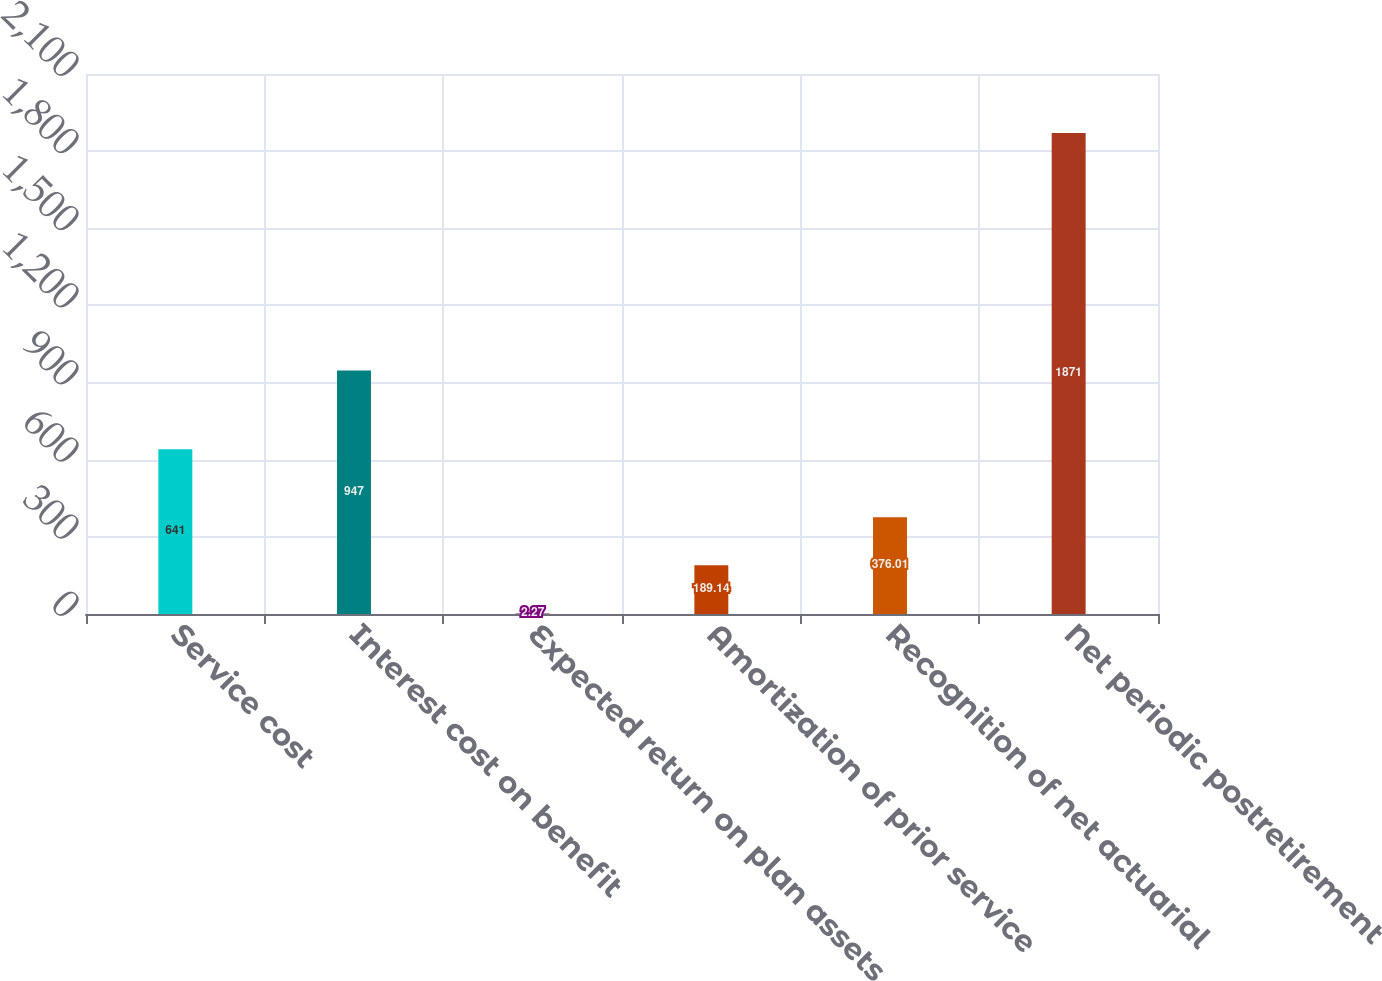<chart> <loc_0><loc_0><loc_500><loc_500><bar_chart><fcel>Service cost<fcel>Interest cost on benefit<fcel>Expected return on plan assets<fcel>Amortization of prior service<fcel>Recognition of net actuarial<fcel>Net periodic postretirement<nl><fcel>641<fcel>947<fcel>2.27<fcel>189.14<fcel>376.01<fcel>1871<nl></chart> 